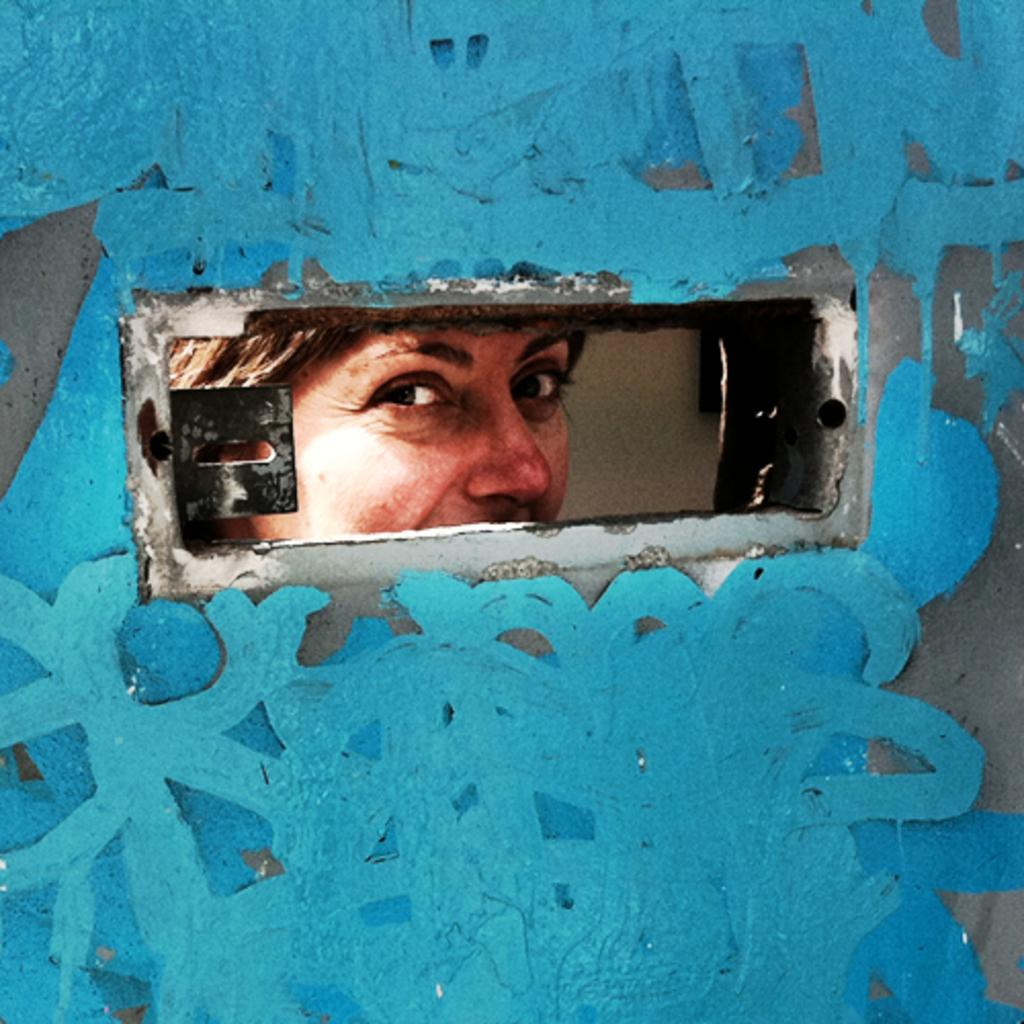What can be seen through the hole in the image? There is a person visible through a hole in the image. What is located behind the person in the image? There is a wall in the background of the image. What decorations are present on the wall? There are paintings visible on the wall. What type of robin is perched on the person's shoulder in the image? There is no robin present in the image; only a person can be seen through the hole. 